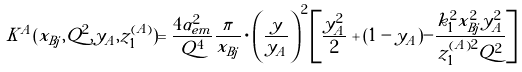<formula> <loc_0><loc_0><loc_500><loc_500>K ^ { A } ( x _ { B j } , Q ^ { 2 } , y _ { A } , z _ { 1 } ^ { ( A ) } ) = \frac { 4 \alpha _ { e m } ^ { 2 } } { Q ^ { 4 } } \frac { \pi } { x _ { B j } } \cdot \left ( \frac { y } { y _ { A } } \right ) ^ { 2 } \left [ \frac { y _ { A } ^ { 2 } } { 2 } + ( 1 - y _ { A } ) - \frac { k _ { 1 } ^ { 2 } x _ { B j } ^ { 2 } y _ { A } ^ { 2 } } { z _ { 1 } ^ { ( A ) 2 } Q ^ { 2 } } \right ]</formula> 